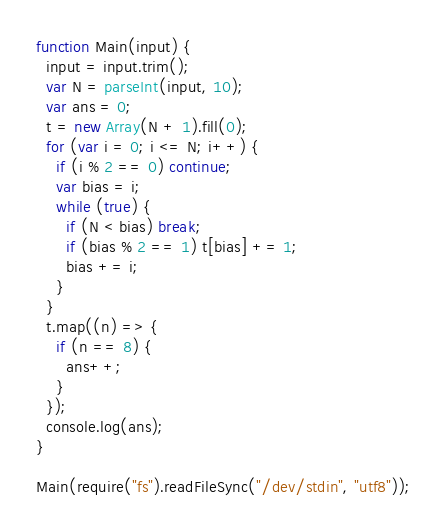<code> <loc_0><loc_0><loc_500><loc_500><_JavaScript_>function Main(input) {
  input = input.trim();
  var N = parseInt(input, 10);
  var ans = 0;
  t = new Array(N + 1).fill(0);
  for (var i = 0; i <= N; i++) {
    if (i % 2 == 0) continue;
    var bias = i;
    while (true) {
      if (N < bias) break;
      if (bias % 2 == 1) t[bias] += 1;
      bias += i;
    }
  }
  t.map((n) => {
    if (n == 8) {
      ans++;
    }
  });
  console.log(ans);
}

Main(require("fs").readFileSync("/dev/stdin", "utf8"));
</code> 